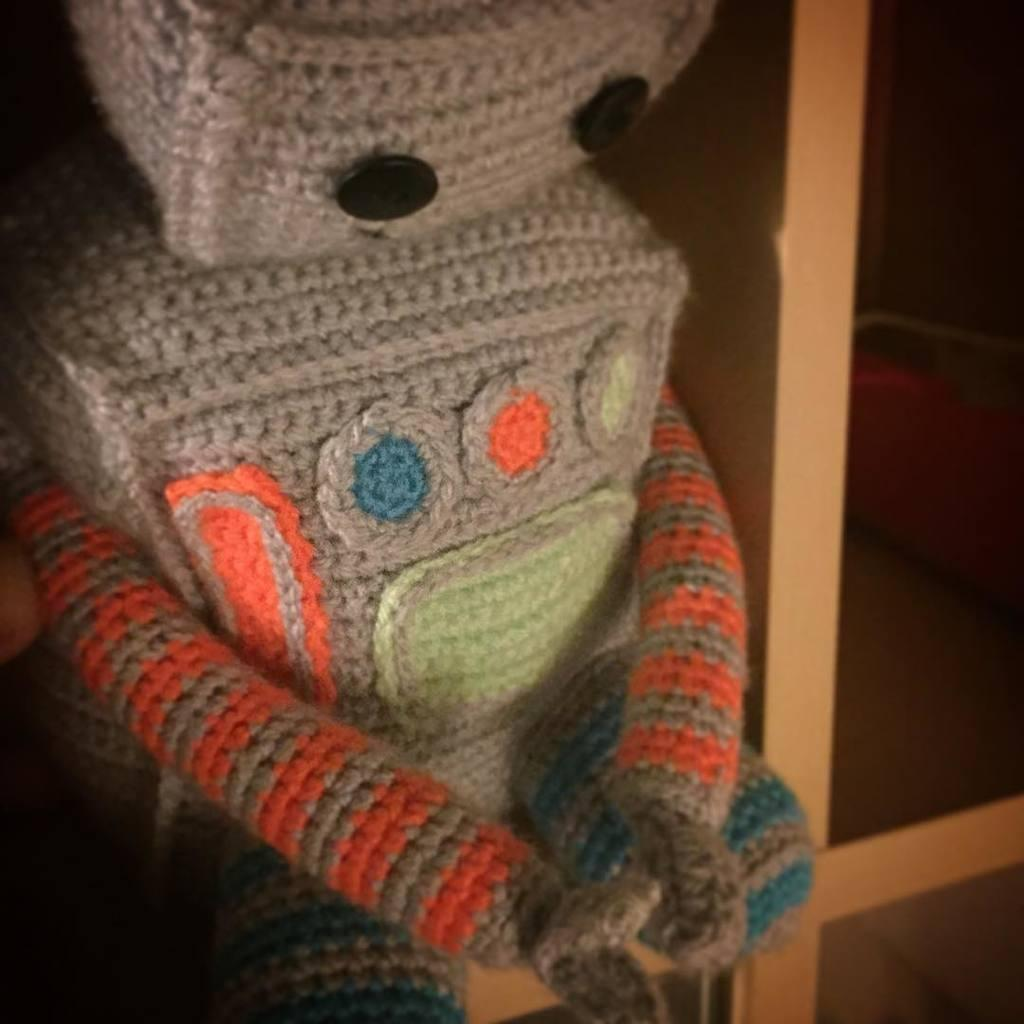What is the main object in the picture? There is a toy in the picture. Where is the toy located? The toy is placed on a wooden shelf. What color are the buttons on the toy? The toy has black color buttons. What type of knife is being used by the toy in the image? There is no knife present in the image, and the toy is not using any tool or object. 